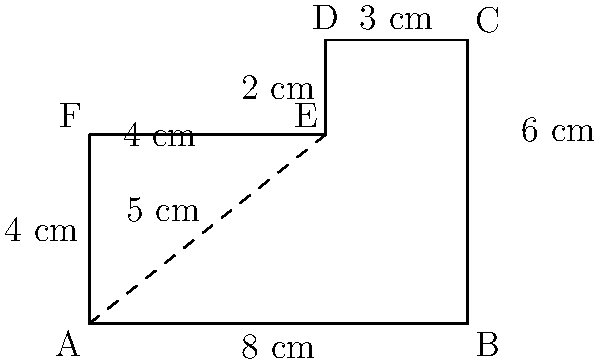You're designing a custom cutting board for your kitchen. The board has an irregular shape as shown in the diagram. Calculate the perimeter of this cutting board. Use the Pythagorean theorem where necessary. Let's break this down step-by-step:

1) First, we'll identify the known lengths:
   AB = 8 cm
   BC = 6 cm
   CD = 3 cm
   DE = 2 cm
   EF = 4 cm
   FA = 4 cm

2) We need to calculate AE using the Pythagorean theorem:
   $AE^2 = 4^2 + 3^2 = 16 + 9 = 25$
   $AE = \sqrt{25} = 5$ cm

3) Now we can calculate the perimeter by adding all the sides:
   Perimeter = AB + BC + CD + DE + EF + FA
             = 8 + 6 + 3 + 2 + 4 + 4
             = 27 cm

Therefore, the perimeter of the cutting board is 27 cm.
Answer: 27 cm 